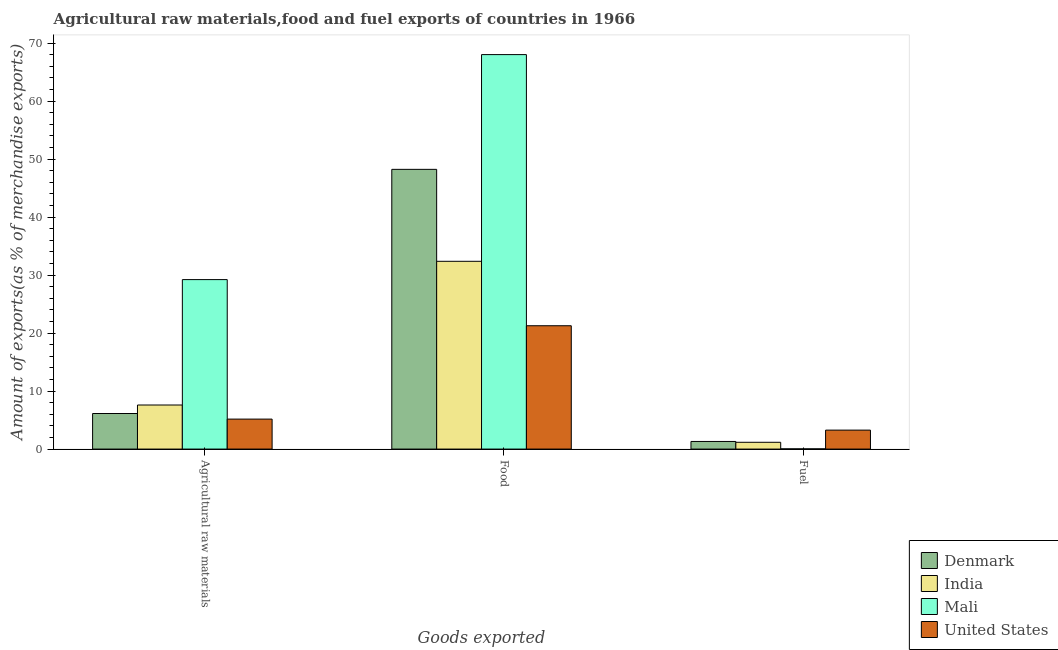Are the number of bars per tick equal to the number of legend labels?
Provide a short and direct response. Yes. Are the number of bars on each tick of the X-axis equal?
Your response must be concise. Yes. How many bars are there on the 1st tick from the left?
Provide a short and direct response. 4. How many bars are there on the 3rd tick from the right?
Your answer should be compact. 4. What is the label of the 2nd group of bars from the left?
Offer a terse response. Food. What is the percentage of fuel exports in United States?
Your answer should be very brief. 3.27. Across all countries, what is the maximum percentage of fuel exports?
Ensure brevity in your answer.  3.27. Across all countries, what is the minimum percentage of fuel exports?
Offer a terse response. 0.04. In which country was the percentage of food exports maximum?
Provide a short and direct response. Mali. What is the total percentage of raw materials exports in the graph?
Provide a succinct answer. 48.12. What is the difference between the percentage of raw materials exports in Mali and that in United States?
Offer a very short reply. 24.06. What is the difference between the percentage of food exports in United States and the percentage of raw materials exports in Denmark?
Ensure brevity in your answer.  15.14. What is the average percentage of food exports per country?
Your answer should be compact. 42.48. What is the difference between the percentage of food exports and percentage of fuel exports in India?
Provide a succinct answer. 31.21. What is the ratio of the percentage of raw materials exports in Denmark to that in India?
Keep it short and to the point. 0.81. Is the percentage of fuel exports in United States less than that in Mali?
Make the answer very short. No. Is the difference between the percentage of fuel exports in India and Denmark greater than the difference between the percentage of food exports in India and Denmark?
Provide a short and direct response. Yes. What is the difference between the highest and the second highest percentage of fuel exports?
Give a very brief answer. 1.96. What is the difference between the highest and the lowest percentage of raw materials exports?
Provide a short and direct response. 24.06. In how many countries, is the percentage of fuel exports greater than the average percentage of fuel exports taken over all countries?
Your response must be concise. 1. What does the 4th bar from the left in Food represents?
Your response must be concise. United States. What does the 2nd bar from the right in Food represents?
Keep it short and to the point. Mali. How many bars are there?
Offer a very short reply. 12. Are all the bars in the graph horizontal?
Make the answer very short. No. What is the difference between two consecutive major ticks on the Y-axis?
Make the answer very short. 10. Are the values on the major ticks of Y-axis written in scientific E-notation?
Your answer should be compact. No. Where does the legend appear in the graph?
Offer a terse response. Bottom right. How are the legend labels stacked?
Make the answer very short. Vertical. What is the title of the graph?
Ensure brevity in your answer.  Agricultural raw materials,food and fuel exports of countries in 1966. What is the label or title of the X-axis?
Your answer should be compact. Goods exported. What is the label or title of the Y-axis?
Make the answer very short. Amount of exports(as % of merchandise exports). What is the Amount of exports(as % of merchandise exports) in Denmark in Agricultural raw materials?
Your response must be concise. 6.13. What is the Amount of exports(as % of merchandise exports) of India in Agricultural raw materials?
Provide a short and direct response. 7.6. What is the Amount of exports(as % of merchandise exports) in Mali in Agricultural raw materials?
Your answer should be compact. 29.22. What is the Amount of exports(as % of merchandise exports) of United States in Agricultural raw materials?
Ensure brevity in your answer.  5.17. What is the Amount of exports(as % of merchandise exports) of Denmark in Food?
Offer a terse response. 48.24. What is the Amount of exports(as % of merchandise exports) in India in Food?
Offer a terse response. 32.38. What is the Amount of exports(as % of merchandise exports) of Mali in Food?
Your answer should be very brief. 68.02. What is the Amount of exports(as % of merchandise exports) of United States in Food?
Offer a very short reply. 21.27. What is the Amount of exports(as % of merchandise exports) of Denmark in Fuel?
Your answer should be compact. 1.31. What is the Amount of exports(as % of merchandise exports) of India in Fuel?
Offer a very short reply. 1.17. What is the Amount of exports(as % of merchandise exports) of Mali in Fuel?
Your answer should be compact. 0.04. What is the Amount of exports(as % of merchandise exports) of United States in Fuel?
Provide a succinct answer. 3.27. Across all Goods exported, what is the maximum Amount of exports(as % of merchandise exports) of Denmark?
Your answer should be very brief. 48.24. Across all Goods exported, what is the maximum Amount of exports(as % of merchandise exports) of India?
Offer a very short reply. 32.38. Across all Goods exported, what is the maximum Amount of exports(as % of merchandise exports) of Mali?
Your answer should be very brief. 68.02. Across all Goods exported, what is the maximum Amount of exports(as % of merchandise exports) of United States?
Your answer should be very brief. 21.27. Across all Goods exported, what is the minimum Amount of exports(as % of merchandise exports) in Denmark?
Your answer should be very brief. 1.31. Across all Goods exported, what is the minimum Amount of exports(as % of merchandise exports) of India?
Your answer should be compact. 1.17. Across all Goods exported, what is the minimum Amount of exports(as % of merchandise exports) of Mali?
Provide a succinct answer. 0.04. Across all Goods exported, what is the minimum Amount of exports(as % of merchandise exports) of United States?
Ensure brevity in your answer.  3.27. What is the total Amount of exports(as % of merchandise exports) of Denmark in the graph?
Provide a short and direct response. 55.68. What is the total Amount of exports(as % of merchandise exports) in India in the graph?
Keep it short and to the point. 41.15. What is the total Amount of exports(as % of merchandise exports) in Mali in the graph?
Provide a succinct answer. 97.28. What is the total Amount of exports(as % of merchandise exports) of United States in the graph?
Keep it short and to the point. 29.71. What is the difference between the Amount of exports(as % of merchandise exports) in Denmark in Agricultural raw materials and that in Food?
Offer a very short reply. -42.1. What is the difference between the Amount of exports(as % of merchandise exports) in India in Agricultural raw materials and that in Food?
Your response must be concise. -24.78. What is the difference between the Amount of exports(as % of merchandise exports) in Mali in Agricultural raw materials and that in Food?
Make the answer very short. -38.8. What is the difference between the Amount of exports(as % of merchandise exports) of United States in Agricultural raw materials and that in Food?
Your answer should be very brief. -16.1. What is the difference between the Amount of exports(as % of merchandise exports) of Denmark in Agricultural raw materials and that in Fuel?
Offer a very short reply. 4.82. What is the difference between the Amount of exports(as % of merchandise exports) in India in Agricultural raw materials and that in Fuel?
Ensure brevity in your answer.  6.43. What is the difference between the Amount of exports(as % of merchandise exports) of Mali in Agricultural raw materials and that in Fuel?
Provide a short and direct response. 29.19. What is the difference between the Amount of exports(as % of merchandise exports) of United States in Agricultural raw materials and that in Fuel?
Keep it short and to the point. 1.9. What is the difference between the Amount of exports(as % of merchandise exports) of Denmark in Food and that in Fuel?
Provide a short and direct response. 46.92. What is the difference between the Amount of exports(as % of merchandise exports) of India in Food and that in Fuel?
Provide a short and direct response. 31.21. What is the difference between the Amount of exports(as % of merchandise exports) in Mali in Food and that in Fuel?
Your response must be concise. 67.99. What is the difference between the Amount of exports(as % of merchandise exports) in United States in Food and that in Fuel?
Give a very brief answer. 18. What is the difference between the Amount of exports(as % of merchandise exports) of Denmark in Agricultural raw materials and the Amount of exports(as % of merchandise exports) of India in Food?
Keep it short and to the point. -26.25. What is the difference between the Amount of exports(as % of merchandise exports) in Denmark in Agricultural raw materials and the Amount of exports(as % of merchandise exports) in Mali in Food?
Keep it short and to the point. -61.89. What is the difference between the Amount of exports(as % of merchandise exports) of Denmark in Agricultural raw materials and the Amount of exports(as % of merchandise exports) of United States in Food?
Provide a short and direct response. -15.14. What is the difference between the Amount of exports(as % of merchandise exports) of India in Agricultural raw materials and the Amount of exports(as % of merchandise exports) of Mali in Food?
Provide a succinct answer. -60.42. What is the difference between the Amount of exports(as % of merchandise exports) of India in Agricultural raw materials and the Amount of exports(as % of merchandise exports) of United States in Food?
Give a very brief answer. -13.67. What is the difference between the Amount of exports(as % of merchandise exports) of Mali in Agricultural raw materials and the Amount of exports(as % of merchandise exports) of United States in Food?
Ensure brevity in your answer.  7.95. What is the difference between the Amount of exports(as % of merchandise exports) in Denmark in Agricultural raw materials and the Amount of exports(as % of merchandise exports) in India in Fuel?
Your response must be concise. 4.96. What is the difference between the Amount of exports(as % of merchandise exports) in Denmark in Agricultural raw materials and the Amount of exports(as % of merchandise exports) in Mali in Fuel?
Provide a short and direct response. 6.1. What is the difference between the Amount of exports(as % of merchandise exports) of Denmark in Agricultural raw materials and the Amount of exports(as % of merchandise exports) of United States in Fuel?
Your response must be concise. 2.86. What is the difference between the Amount of exports(as % of merchandise exports) in India in Agricultural raw materials and the Amount of exports(as % of merchandise exports) in Mali in Fuel?
Keep it short and to the point. 7.56. What is the difference between the Amount of exports(as % of merchandise exports) of India in Agricultural raw materials and the Amount of exports(as % of merchandise exports) of United States in Fuel?
Provide a short and direct response. 4.33. What is the difference between the Amount of exports(as % of merchandise exports) in Mali in Agricultural raw materials and the Amount of exports(as % of merchandise exports) in United States in Fuel?
Offer a very short reply. 25.95. What is the difference between the Amount of exports(as % of merchandise exports) in Denmark in Food and the Amount of exports(as % of merchandise exports) in India in Fuel?
Provide a short and direct response. 47.07. What is the difference between the Amount of exports(as % of merchandise exports) in Denmark in Food and the Amount of exports(as % of merchandise exports) in Mali in Fuel?
Ensure brevity in your answer.  48.2. What is the difference between the Amount of exports(as % of merchandise exports) in Denmark in Food and the Amount of exports(as % of merchandise exports) in United States in Fuel?
Provide a succinct answer. 44.97. What is the difference between the Amount of exports(as % of merchandise exports) of India in Food and the Amount of exports(as % of merchandise exports) of Mali in Fuel?
Your answer should be compact. 32.34. What is the difference between the Amount of exports(as % of merchandise exports) in India in Food and the Amount of exports(as % of merchandise exports) in United States in Fuel?
Provide a succinct answer. 29.11. What is the difference between the Amount of exports(as % of merchandise exports) of Mali in Food and the Amount of exports(as % of merchandise exports) of United States in Fuel?
Offer a terse response. 64.75. What is the average Amount of exports(as % of merchandise exports) in Denmark per Goods exported?
Ensure brevity in your answer.  18.56. What is the average Amount of exports(as % of merchandise exports) of India per Goods exported?
Ensure brevity in your answer.  13.72. What is the average Amount of exports(as % of merchandise exports) of Mali per Goods exported?
Your response must be concise. 32.43. What is the average Amount of exports(as % of merchandise exports) of United States per Goods exported?
Offer a terse response. 9.9. What is the difference between the Amount of exports(as % of merchandise exports) in Denmark and Amount of exports(as % of merchandise exports) in India in Agricultural raw materials?
Make the answer very short. -1.47. What is the difference between the Amount of exports(as % of merchandise exports) of Denmark and Amount of exports(as % of merchandise exports) of Mali in Agricultural raw materials?
Give a very brief answer. -23.09. What is the difference between the Amount of exports(as % of merchandise exports) of Denmark and Amount of exports(as % of merchandise exports) of United States in Agricultural raw materials?
Your response must be concise. 0.97. What is the difference between the Amount of exports(as % of merchandise exports) of India and Amount of exports(as % of merchandise exports) of Mali in Agricultural raw materials?
Make the answer very short. -21.62. What is the difference between the Amount of exports(as % of merchandise exports) in India and Amount of exports(as % of merchandise exports) in United States in Agricultural raw materials?
Provide a short and direct response. 2.43. What is the difference between the Amount of exports(as % of merchandise exports) in Mali and Amount of exports(as % of merchandise exports) in United States in Agricultural raw materials?
Your answer should be very brief. 24.06. What is the difference between the Amount of exports(as % of merchandise exports) of Denmark and Amount of exports(as % of merchandise exports) of India in Food?
Offer a very short reply. 15.86. What is the difference between the Amount of exports(as % of merchandise exports) of Denmark and Amount of exports(as % of merchandise exports) of Mali in Food?
Ensure brevity in your answer.  -19.79. What is the difference between the Amount of exports(as % of merchandise exports) of Denmark and Amount of exports(as % of merchandise exports) of United States in Food?
Offer a terse response. 26.97. What is the difference between the Amount of exports(as % of merchandise exports) in India and Amount of exports(as % of merchandise exports) in Mali in Food?
Keep it short and to the point. -35.64. What is the difference between the Amount of exports(as % of merchandise exports) of India and Amount of exports(as % of merchandise exports) of United States in Food?
Provide a succinct answer. 11.11. What is the difference between the Amount of exports(as % of merchandise exports) of Mali and Amount of exports(as % of merchandise exports) of United States in Food?
Your answer should be compact. 46.76. What is the difference between the Amount of exports(as % of merchandise exports) of Denmark and Amount of exports(as % of merchandise exports) of India in Fuel?
Your answer should be very brief. 0.14. What is the difference between the Amount of exports(as % of merchandise exports) in Denmark and Amount of exports(as % of merchandise exports) in Mali in Fuel?
Your response must be concise. 1.28. What is the difference between the Amount of exports(as % of merchandise exports) of Denmark and Amount of exports(as % of merchandise exports) of United States in Fuel?
Offer a terse response. -1.96. What is the difference between the Amount of exports(as % of merchandise exports) of India and Amount of exports(as % of merchandise exports) of Mali in Fuel?
Make the answer very short. 1.13. What is the difference between the Amount of exports(as % of merchandise exports) in India and Amount of exports(as % of merchandise exports) in United States in Fuel?
Your answer should be very brief. -2.1. What is the difference between the Amount of exports(as % of merchandise exports) of Mali and Amount of exports(as % of merchandise exports) of United States in Fuel?
Offer a terse response. -3.23. What is the ratio of the Amount of exports(as % of merchandise exports) in Denmark in Agricultural raw materials to that in Food?
Provide a succinct answer. 0.13. What is the ratio of the Amount of exports(as % of merchandise exports) of India in Agricultural raw materials to that in Food?
Offer a terse response. 0.23. What is the ratio of the Amount of exports(as % of merchandise exports) of Mali in Agricultural raw materials to that in Food?
Your answer should be very brief. 0.43. What is the ratio of the Amount of exports(as % of merchandise exports) of United States in Agricultural raw materials to that in Food?
Offer a very short reply. 0.24. What is the ratio of the Amount of exports(as % of merchandise exports) of Denmark in Agricultural raw materials to that in Fuel?
Keep it short and to the point. 4.67. What is the ratio of the Amount of exports(as % of merchandise exports) in India in Agricultural raw materials to that in Fuel?
Offer a terse response. 6.49. What is the ratio of the Amount of exports(as % of merchandise exports) in Mali in Agricultural raw materials to that in Fuel?
Make the answer very short. 806.43. What is the ratio of the Amount of exports(as % of merchandise exports) of United States in Agricultural raw materials to that in Fuel?
Offer a terse response. 1.58. What is the ratio of the Amount of exports(as % of merchandise exports) in Denmark in Food to that in Fuel?
Offer a terse response. 36.75. What is the ratio of the Amount of exports(as % of merchandise exports) of India in Food to that in Fuel?
Provide a short and direct response. 27.66. What is the ratio of the Amount of exports(as % of merchandise exports) in Mali in Food to that in Fuel?
Offer a very short reply. 1877.17. What is the ratio of the Amount of exports(as % of merchandise exports) of United States in Food to that in Fuel?
Offer a very short reply. 6.51. What is the difference between the highest and the second highest Amount of exports(as % of merchandise exports) of Denmark?
Your answer should be compact. 42.1. What is the difference between the highest and the second highest Amount of exports(as % of merchandise exports) of India?
Provide a short and direct response. 24.78. What is the difference between the highest and the second highest Amount of exports(as % of merchandise exports) of Mali?
Give a very brief answer. 38.8. What is the difference between the highest and the second highest Amount of exports(as % of merchandise exports) of United States?
Ensure brevity in your answer.  16.1. What is the difference between the highest and the lowest Amount of exports(as % of merchandise exports) of Denmark?
Give a very brief answer. 46.92. What is the difference between the highest and the lowest Amount of exports(as % of merchandise exports) of India?
Keep it short and to the point. 31.21. What is the difference between the highest and the lowest Amount of exports(as % of merchandise exports) in Mali?
Provide a succinct answer. 67.99. What is the difference between the highest and the lowest Amount of exports(as % of merchandise exports) in United States?
Give a very brief answer. 18. 